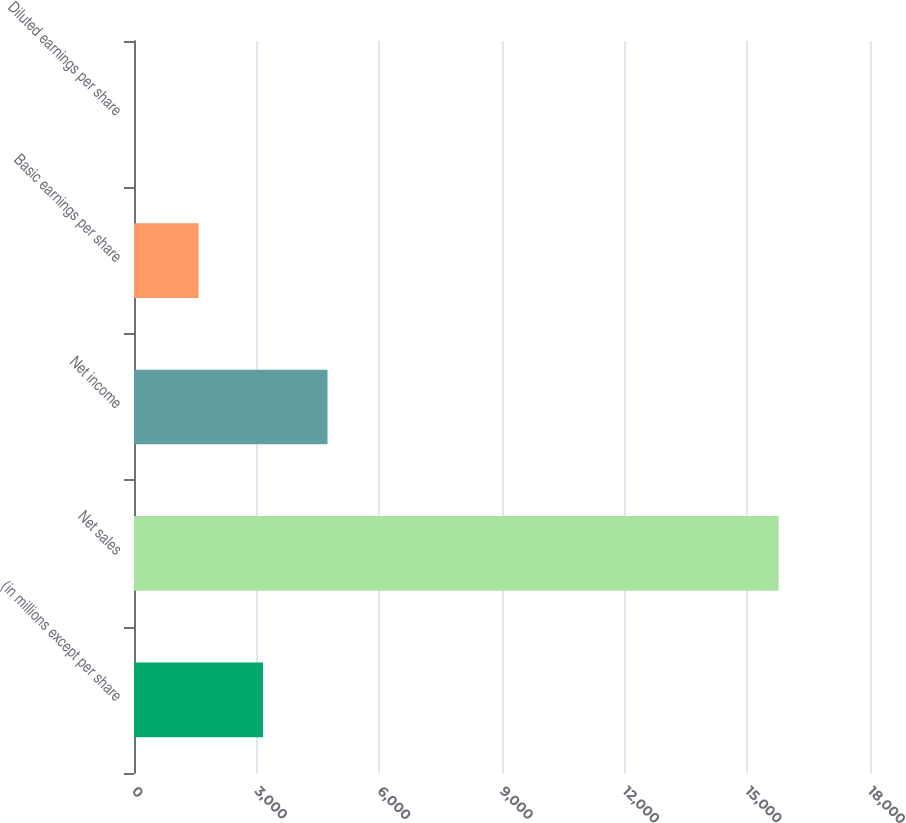Convert chart. <chart><loc_0><loc_0><loc_500><loc_500><bar_chart><fcel>(in millions except per share<fcel>Net sales<fcel>Net income<fcel>Basic earnings per share<fcel>Diluted earnings per share<nl><fcel>3156.31<fcel>15767<fcel>4732.65<fcel>1579.97<fcel>3.63<nl></chart> 